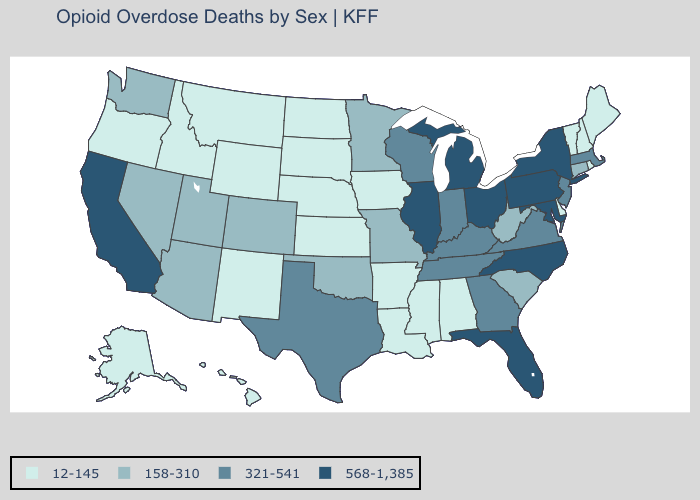Does New Mexico have the highest value in the West?
Give a very brief answer. No. Does the map have missing data?
Quick response, please. No. Which states have the lowest value in the USA?
Keep it brief. Alabama, Alaska, Arkansas, Delaware, Hawaii, Idaho, Iowa, Kansas, Louisiana, Maine, Mississippi, Montana, Nebraska, New Hampshire, New Mexico, North Dakota, Oregon, Rhode Island, South Dakota, Vermont, Wyoming. What is the value of Indiana?
Give a very brief answer. 321-541. What is the lowest value in the South?
Write a very short answer. 12-145. Name the states that have a value in the range 158-310?
Short answer required. Arizona, Colorado, Connecticut, Minnesota, Missouri, Nevada, Oklahoma, South Carolina, Utah, Washington, West Virginia. Does the first symbol in the legend represent the smallest category?
Short answer required. Yes. What is the value of Connecticut?
Be succinct. 158-310. What is the highest value in the USA?
Answer briefly. 568-1,385. Name the states that have a value in the range 12-145?
Keep it brief. Alabama, Alaska, Arkansas, Delaware, Hawaii, Idaho, Iowa, Kansas, Louisiana, Maine, Mississippi, Montana, Nebraska, New Hampshire, New Mexico, North Dakota, Oregon, Rhode Island, South Dakota, Vermont, Wyoming. Does Virginia have the lowest value in the USA?
Quick response, please. No. Name the states that have a value in the range 321-541?
Short answer required. Georgia, Indiana, Kentucky, Massachusetts, New Jersey, Tennessee, Texas, Virginia, Wisconsin. Name the states that have a value in the range 158-310?
Keep it brief. Arizona, Colorado, Connecticut, Minnesota, Missouri, Nevada, Oklahoma, South Carolina, Utah, Washington, West Virginia. Does California have the highest value in the West?
Quick response, please. Yes. Among the states that border Louisiana , does Mississippi have the lowest value?
Answer briefly. Yes. 